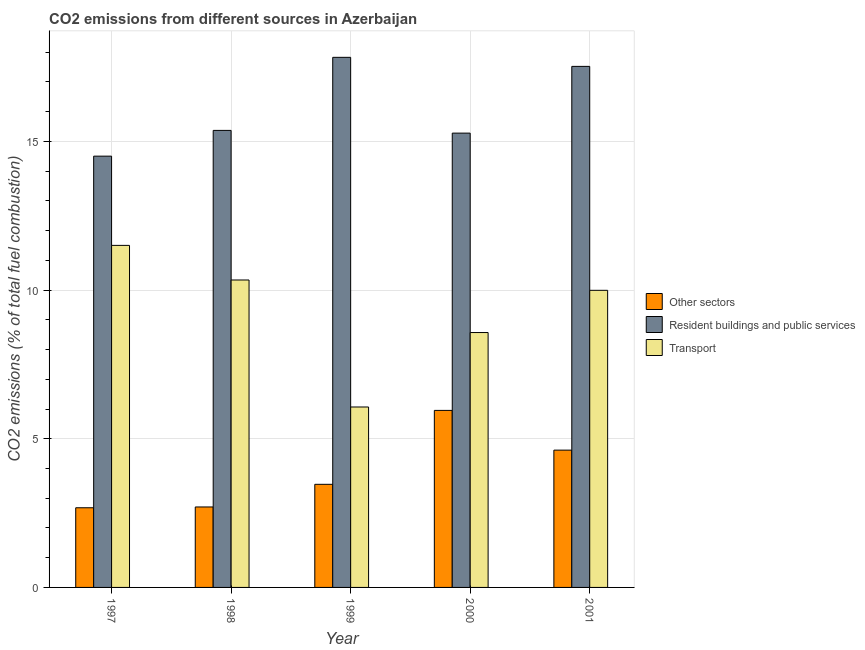How many different coloured bars are there?
Your answer should be compact. 3. How many bars are there on the 5th tick from the left?
Keep it short and to the point. 3. What is the label of the 1st group of bars from the left?
Your response must be concise. 1997. In how many cases, is the number of bars for a given year not equal to the number of legend labels?
Offer a very short reply. 0. What is the percentage of co2 emissions from resident buildings and public services in 1997?
Offer a very short reply. 14.51. Across all years, what is the maximum percentage of co2 emissions from other sectors?
Make the answer very short. 5.95. Across all years, what is the minimum percentage of co2 emissions from other sectors?
Keep it short and to the point. 2.68. What is the total percentage of co2 emissions from other sectors in the graph?
Make the answer very short. 19.43. What is the difference between the percentage of co2 emissions from resident buildings and public services in 1997 and that in 1999?
Ensure brevity in your answer.  -3.32. What is the difference between the percentage of co2 emissions from other sectors in 2000 and the percentage of co2 emissions from resident buildings and public services in 2001?
Keep it short and to the point. 1.34. What is the average percentage of co2 emissions from transport per year?
Offer a very short reply. 9.3. In the year 1998, what is the difference between the percentage of co2 emissions from other sectors and percentage of co2 emissions from transport?
Your answer should be very brief. 0. What is the ratio of the percentage of co2 emissions from other sectors in 1997 to that in 1999?
Provide a succinct answer. 0.77. Is the percentage of co2 emissions from resident buildings and public services in 1997 less than that in 2000?
Offer a terse response. Yes. What is the difference between the highest and the second highest percentage of co2 emissions from resident buildings and public services?
Your response must be concise. 0.3. What is the difference between the highest and the lowest percentage of co2 emissions from transport?
Give a very brief answer. 5.44. In how many years, is the percentage of co2 emissions from resident buildings and public services greater than the average percentage of co2 emissions from resident buildings and public services taken over all years?
Provide a short and direct response. 2. Is the sum of the percentage of co2 emissions from transport in 1999 and 2000 greater than the maximum percentage of co2 emissions from other sectors across all years?
Offer a very short reply. Yes. What does the 3rd bar from the left in 2001 represents?
Make the answer very short. Transport. What does the 1st bar from the right in 2001 represents?
Your answer should be very brief. Transport. How many bars are there?
Provide a succinct answer. 15. Are all the bars in the graph horizontal?
Offer a very short reply. No. How many years are there in the graph?
Make the answer very short. 5. Does the graph contain grids?
Keep it short and to the point. Yes. Where does the legend appear in the graph?
Ensure brevity in your answer.  Center right. What is the title of the graph?
Provide a succinct answer. CO2 emissions from different sources in Azerbaijan. What is the label or title of the Y-axis?
Keep it short and to the point. CO2 emissions (% of total fuel combustion). What is the CO2 emissions (% of total fuel combustion) in Other sectors in 1997?
Keep it short and to the point. 2.68. What is the CO2 emissions (% of total fuel combustion) of Resident buildings and public services in 1997?
Your answer should be very brief. 14.51. What is the CO2 emissions (% of total fuel combustion) in Transport in 1997?
Give a very brief answer. 11.5. What is the CO2 emissions (% of total fuel combustion) of Other sectors in 1998?
Offer a terse response. 2.71. What is the CO2 emissions (% of total fuel combustion) of Resident buildings and public services in 1998?
Your answer should be compact. 15.37. What is the CO2 emissions (% of total fuel combustion) in Transport in 1998?
Your response must be concise. 10.34. What is the CO2 emissions (% of total fuel combustion) in Other sectors in 1999?
Provide a succinct answer. 3.47. What is the CO2 emissions (% of total fuel combustion) in Resident buildings and public services in 1999?
Give a very brief answer. 17.83. What is the CO2 emissions (% of total fuel combustion) in Transport in 1999?
Your response must be concise. 6.07. What is the CO2 emissions (% of total fuel combustion) of Other sectors in 2000?
Give a very brief answer. 5.95. What is the CO2 emissions (% of total fuel combustion) in Resident buildings and public services in 2000?
Give a very brief answer. 15.28. What is the CO2 emissions (% of total fuel combustion) in Transport in 2000?
Make the answer very short. 8.57. What is the CO2 emissions (% of total fuel combustion) of Other sectors in 2001?
Provide a succinct answer. 4.62. What is the CO2 emissions (% of total fuel combustion) of Resident buildings and public services in 2001?
Your response must be concise. 17.52. What is the CO2 emissions (% of total fuel combustion) in Transport in 2001?
Provide a succinct answer. 9.99. Across all years, what is the maximum CO2 emissions (% of total fuel combustion) in Other sectors?
Your response must be concise. 5.95. Across all years, what is the maximum CO2 emissions (% of total fuel combustion) of Resident buildings and public services?
Offer a terse response. 17.83. Across all years, what is the maximum CO2 emissions (% of total fuel combustion) of Transport?
Ensure brevity in your answer.  11.5. Across all years, what is the minimum CO2 emissions (% of total fuel combustion) of Other sectors?
Make the answer very short. 2.68. Across all years, what is the minimum CO2 emissions (% of total fuel combustion) of Resident buildings and public services?
Give a very brief answer. 14.51. Across all years, what is the minimum CO2 emissions (% of total fuel combustion) in Transport?
Offer a very short reply. 6.07. What is the total CO2 emissions (% of total fuel combustion) of Other sectors in the graph?
Your answer should be very brief. 19.43. What is the total CO2 emissions (% of total fuel combustion) of Resident buildings and public services in the graph?
Ensure brevity in your answer.  80.51. What is the total CO2 emissions (% of total fuel combustion) of Transport in the graph?
Keep it short and to the point. 46.48. What is the difference between the CO2 emissions (% of total fuel combustion) in Other sectors in 1997 and that in 1998?
Provide a short and direct response. -0.03. What is the difference between the CO2 emissions (% of total fuel combustion) in Resident buildings and public services in 1997 and that in 1998?
Give a very brief answer. -0.87. What is the difference between the CO2 emissions (% of total fuel combustion) in Transport in 1997 and that in 1998?
Offer a terse response. 1.16. What is the difference between the CO2 emissions (% of total fuel combustion) of Other sectors in 1997 and that in 1999?
Provide a succinct answer. -0.79. What is the difference between the CO2 emissions (% of total fuel combustion) in Resident buildings and public services in 1997 and that in 1999?
Ensure brevity in your answer.  -3.32. What is the difference between the CO2 emissions (% of total fuel combustion) of Transport in 1997 and that in 1999?
Your response must be concise. 5.44. What is the difference between the CO2 emissions (% of total fuel combustion) of Other sectors in 1997 and that in 2000?
Ensure brevity in your answer.  -3.27. What is the difference between the CO2 emissions (% of total fuel combustion) in Resident buildings and public services in 1997 and that in 2000?
Ensure brevity in your answer.  -0.77. What is the difference between the CO2 emissions (% of total fuel combustion) in Transport in 1997 and that in 2000?
Your answer should be very brief. 2.93. What is the difference between the CO2 emissions (% of total fuel combustion) in Other sectors in 1997 and that in 2001?
Provide a succinct answer. -1.94. What is the difference between the CO2 emissions (% of total fuel combustion) of Resident buildings and public services in 1997 and that in 2001?
Make the answer very short. -3.02. What is the difference between the CO2 emissions (% of total fuel combustion) of Transport in 1997 and that in 2001?
Keep it short and to the point. 1.51. What is the difference between the CO2 emissions (% of total fuel combustion) of Other sectors in 1998 and that in 1999?
Your response must be concise. -0.76. What is the difference between the CO2 emissions (% of total fuel combustion) of Resident buildings and public services in 1998 and that in 1999?
Your response must be concise. -2.46. What is the difference between the CO2 emissions (% of total fuel combustion) in Transport in 1998 and that in 1999?
Your answer should be compact. 4.27. What is the difference between the CO2 emissions (% of total fuel combustion) in Other sectors in 1998 and that in 2000?
Provide a short and direct response. -3.25. What is the difference between the CO2 emissions (% of total fuel combustion) of Resident buildings and public services in 1998 and that in 2000?
Provide a succinct answer. 0.09. What is the difference between the CO2 emissions (% of total fuel combustion) in Transport in 1998 and that in 2000?
Keep it short and to the point. 1.77. What is the difference between the CO2 emissions (% of total fuel combustion) of Other sectors in 1998 and that in 2001?
Offer a terse response. -1.91. What is the difference between the CO2 emissions (% of total fuel combustion) in Resident buildings and public services in 1998 and that in 2001?
Your answer should be very brief. -2.15. What is the difference between the CO2 emissions (% of total fuel combustion) in Transport in 1998 and that in 2001?
Ensure brevity in your answer.  0.35. What is the difference between the CO2 emissions (% of total fuel combustion) in Other sectors in 1999 and that in 2000?
Make the answer very short. -2.49. What is the difference between the CO2 emissions (% of total fuel combustion) of Resident buildings and public services in 1999 and that in 2000?
Your response must be concise. 2.55. What is the difference between the CO2 emissions (% of total fuel combustion) in Transport in 1999 and that in 2000?
Make the answer very short. -2.5. What is the difference between the CO2 emissions (% of total fuel combustion) of Other sectors in 1999 and that in 2001?
Your answer should be very brief. -1.15. What is the difference between the CO2 emissions (% of total fuel combustion) of Resident buildings and public services in 1999 and that in 2001?
Provide a succinct answer. 0.3. What is the difference between the CO2 emissions (% of total fuel combustion) in Transport in 1999 and that in 2001?
Your answer should be compact. -3.92. What is the difference between the CO2 emissions (% of total fuel combustion) in Other sectors in 2000 and that in 2001?
Keep it short and to the point. 1.34. What is the difference between the CO2 emissions (% of total fuel combustion) of Resident buildings and public services in 2000 and that in 2001?
Provide a succinct answer. -2.24. What is the difference between the CO2 emissions (% of total fuel combustion) in Transport in 2000 and that in 2001?
Provide a short and direct response. -1.42. What is the difference between the CO2 emissions (% of total fuel combustion) of Other sectors in 1997 and the CO2 emissions (% of total fuel combustion) of Resident buildings and public services in 1998?
Give a very brief answer. -12.69. What is the difference between the CO2 emissions (% of total fuel combustion) of Other sectors in 1997 and the CO2 emissions (% of total fuel combustion) of Transport in 1998?
Your answer should be compact. -7.66. What is the difference between the CO2 emissions (% of total fuel combustion) in Resident buildings and public services in 1997 and the CO2 emissions (% of total fuel combustion) in Transport in 1998?
Your answer should be very brief. 4.17. What is the difference between the CO2 emissions (% of total fuel combustion) of Other sectors in 1997 and the CO2 emissions (% of total fuel combustion) of Resident buildings and public services in 1999?
Ensure brevity in your answer.  -15.15. What is the difference between the CO2 emissions (% of total fuel combustion) in Other sectors in 1997 and the CO2 emissions (% of total fuel combustion) in Transport in 1999?
Give a very brief answer. -3.39. What is the difference between the CO2 emissions (% of total fuel combustion) of Resident buildings and public services in 1997 and the CO2 emissions (% of total fuel combustion) of Transport in 1999?
Provide a short and direct response. 8.44. What is the difference between the CO2 emissions (% of total fuel combustion) of Other sectors in 1997 and the CO2 emissions (% of total fuel combustion) of Resident buildings and public services in 2000?
Provide a succinct answer. -12.6. What is the difference between the CO2 emissions (% of total fuel combustion) in Other sectors in 1997 and the CO2 emissions (% of total fuel combustion) in Transport in 2000?
Provide a succinct answer. -5.89. What is the difference between the CO2 emissions (% of total fuel combustion) of Resident buildings and public services in 1997 and the CO2 emissions (% of total fuel combustion) of Transport in 2000?
Offer a terse response. 5.93. What is the difference between the CO2 emissions (% of total fuel combustion) in Other sectors in 1997 and the CO2 emissions (% of total fuel combustion) in Resident buildings and public services in 2001?
Give a very brief answer. -14.85. What is the difference between the CO2 emissions (% of total fuel combustion) in Other sectors in 1997 and the CO2 emissions (% of total fuel combustion) in Transport in 2001?
Provide a succinct answer. -7.31. What is the difference between the CO2 emissions (% of total fuel combustion) of Resident buildings and public services in 1997 and the CO2 emissions (% of total fuel combustion) of Transport in 2001?
Provide a short and direct response. 4.51. What is the difference between the CO2 emissions (% of total fuel combustion) in Other sectors in 1998 and the CO2 emissions (% of total fuel combustion) in Resident buildings and public services in 1999?
Make the answer very short. -15.12. What is the difference between the CO2 emissions (% of total fuel combustion) of Other sectors in 1998 and the CO2 emissions (% of total fuel combustion) of Transport in 1999?
Your answer should be compact. -3.36. What is the difference between the CO2 emissions (% of total fuel combustion) in Resident buildings and public services in 1998 and the CO2 emissions (% of total fuel combustion) in Transport in 1999?
Offer a very short reply. 9.3. What is the difference between the CO2 emissions (% of total fuel combustion) of Other sectors in 1998 and the CO2 emissions (% of total fuel combustion) of Resident buildings and public services in 2000?
Your response must be concise. -12.57. What is the difference between the CO2 emissions (% of total fuel combustion) of Other sectors in 1998 and the CO2 emissions (% of total fuel combustion) of Transport in 2000?
Your answer should be very brief. -5.87. What is the difference between the CO2 emissions (% of total fuel combustion) in Resident buildings and public services in 1998 and the CO2 emissions (% of total fuel combustion) in Transport in 2000?
Keep it short and to the point. 6.8. What is the difference between the CO2 emissions (% of total fuel combustion) in Other sectors in 1998 and the CO2 emissions (% of total fuel combustion) in Resident buildings and public services in 2001?
Give a very brief answer. -14.82. What is the difference between the CO2 emissions (% of total fuel combustion) in Other sectors in 1998 and the CO2 emissions (% of total fuel combustion) in Transport in 2001?
Your response must be concise. -7.29. What is the difference between the CO2 emissions (% of total fuel combustion) in Resident buildings and public services in 1998 and the CO2 emissions (% of total fuel combustion) in Transport in 2001?
Your answer should be compact. 5.38. What is the difference between the CO2 emissions (% of total fuel combustion) of Other sectors in 1999 and the CO2 emissions (% of total fuel combustion) of Resident buildings and public services in 2000?
Your response must be concise. -11.81. What is the difference between the CO2 emissions (% of total fuel combustion) in Other sectors in 1999 and the CO2 emissions (% of total fuel combustion) in Transport in 2000?
Provide a succinct answer. -5.1. What is the difference between the CO2 emissions (% of total fuel combustion) of Resident buildings and public services in 1999 and the CO2 emissions (% of total fuel combustion) of Transport in 2000?
Your answer should be very brief. 9.26. What is the difference between the CO2 emissions (% of total fuel combustion) of Other sectors in 1999 and the CO2 emissions (% of total fuel combustion) of Resident buildings and public services in 2001?
Provide a short and direct response. -14.06. What is the difference between the CO2 emissions (% of total fuel combustion) of Other sectors in 1999 and the CO2 emissions (% of total fuel combustion) of Transport in 2001?
Your answer should be compact. -6.52. What is the difference between the CO2 emissions (% of total fuel combustion) of Resident buildings and public services in 1999 and the CO2 emissions (% of total fuel combustion) of Transport in 2001?
Provide a short and direct response. 7.84. What is the difference between the CO2 emissions (% of total fuel combustion) in Other sectors in 2000 and the CO2 emissions (% of total fuel combustion) in Resident buildings and public services in 2001?
Provide a short and direct response. -11.57. What is the difference between the CO2 emissions (% of total fuel combustion) of Other sectors in 2000 and the CO2 emissions (% of total fuel combustion) of Transport in 2001?
Ensure brevity in your answer.  -4.04. What is the difference between the CO2 emissions (% of total fuel combustion) of Resident buildings and public services in 2000 and the CO2 emissions (% of total fuel combustion) of Transport in 2001?
Give a very brief answer. 5.29. What is the average CO2 emissions (% of total fuel combustion) in Other sectors per year?
Ensure brevity in your answer.  3.89. What is the average CO2 emissions (% of total fuel combustion) in Resident buildings and public services per year?
Your answer should be compact. 16.1. What is the average CO2 emissions (% of total fuel combustion) in Transport per year?
Ensure brevity in your answer.  9.3. In the year 1997, what is the difference between the CO2 emissions (% of total fuel combustion) in Other sectors and CO2 emissions (% of total fuel combustion) in Resident buildings and public services?
Your response must be concise. -11.83. In the year 1997, what is the difference between the CO2 emissions (% of total fuel combustion) in Other sectors and CO2 emissions (% of total fuel combustion) in Transport?
Your response must be concise. -8.82. In the year 1997, what is the difference between the CO2 emissions (% of total fuel combustion) of Resident buildings and public services and CO2 emissions (% of total fuel combustion) of Transport?
Make the answer very short. 3. In the year 1998, what is the difference between the CO2 emissions (% of total fuel combustion) in Other sectors and CO2 emissions (% of total fuel combustion) in Resident buildings and public services?
Give a very brief answer. -12.66. In the year 1998, what is the difference between the CO2 emissions (% of total fuel combustion) of Other sectors and CO2 emissions (% of total fuel combustion) of Transport?
Offer a terse response. -7.63. In the year 1998, what is the difference between the CO2 emissions (% of total fuel combustion) in Resident buildings and public services and CO2 emissions (% of total fuel combustion) in Transport?
Your response must be concise. 5.03. In the year 1999, what is the difference between the CO2 emissions (% of total fuel combustion) in Other sectors and CO2 emissions (% of total fuel combustion) in Resident buildings and public services?
Provide a succinct answer. -14.36. In the year 1999, what is the difference between the CO2 emissions (% of total fuel combustion) in Other sectors and CO2 emissions (% of total fuel combustion) in Transport?
Provide a succinct answer. -2.6. In the year 1999, what is the difference between the CO2 emissions (% of total fuel combustion) of Resident buildings and public services and CO2 emissions (% of total fuel combustion) of Transport?
Make the answer very short. 11.76. In the year 2000, what is the difference between the CO2 emissions (% of total fuel combustion) in Other sectors and CO2 emissions (% of total fuel combustion) in Resident buildings and public services?
Your answer should be compact. -9.33. In the year 2000, what is the difference between the CO2 emissions (% of total fuel combustion) in Other sectors and CO2 emissions (% of total fuel combustion) in Transport?
Provide a short and direct response. -2.62. In the year 2000, what is the difference between the CO2 emissions (% of total fuel combustion) of Resident buildings and public services and CO2 emissions (% of total fuel combustion) of Transport?
Your answer should be very brief. 6.71. In the year 2001, what is the difference between the CO2 emissions (% of total fuel combustion) in Other sectors and CO2 emissions (% of total fuel combustion) in Resident buildings and public services?
Ensure brevity in your answer.  -12.91. In the year 2001, what is the difference between the CO2 emissions (% of total fuel combustion) in Other sectors and CO2 emissions (% of total fuel combustion) in Transport?
Keep it short and to the point. -5.37. In the year 2001, what is the difference between the CO2 emissions (% of total fuel combustion) in Resident buildings and public services and CO2 emissions (% of total fuel combustion) in Transport?
Your answer should be very brief. 7.53. What is the ratio of the CO2 emissions (% of total fuel combustion) of Resident buildings and public services in 1997 to that in 1998?
Ensure brevity in your answer.  0.94. What is the ratio of the CO2 emissions (% of total fuel combustion) in Transport in 1997 to that in 1998?
Your answer should be compact. 1.11. What is the ratio of the CO2 emissions (% of total fuel combustion) of Other sectors in 1997 to that in 1999?
Offer a very short reply. 0.77. What is the ratio of the CO2 emissions (% of total fuel combustion) in Resident buildings and public services in 1997 to that in 1999?
Your answer should be compact. 0.81. What is the ratio of the CO2 emissions (% of total fuel combustion) in Transport in 1997 to that in 1999?
Ensure brevity in your answer.  1.9. What is the ratio of the CO2 emissions (% of total fuel combustion) in Other sectors in 1997 to that in 2000?
Ensure brevity in your answer.  0.45. What is the ratio of the CO2 emissions (% of total fuel combustion) in Resident buildings and public services in 1997 to that in 2000?
Your answer should be compact. 0.95. What is the ratio of the CO2 emissions (% of total fuel combustion) in Transport in 1997 to that in 2000?
Ensure brevity in your answer.  1.34. What is the ratio of the CO2 emissions (% of total fuel combustion) in Other sectors in 1997 to that in 2001?
Provide a short and direct response. 0.58. What is the ratio of the CO2 emissions (% of total fuel combustion) in Resident buildings and public services in 1997 to that in 2001?
Your answer should be compact. 0.83. What is the ratio of the CO2 emissions (% of total fuel combustion) of Transport in 1997 to that in 2001?
Your answer should be very brief. 1.15. What is the ratio of the CO2 emissions (% of total fuel combustion) in Other sectors in 1998 to that in 1999?
Make the answer very short. 0.78. What is the ratio of the CO2 emissions (% of total fuel combustion) in Resident buildings and public services in 1998 to that in 1999?
Your answer should be compact. 0.86. What is the ratio of the CO2 emissions (% of total fuel combustion) of Transport in 1998 to that in 1999?
Keep it short and to the point. 1.7. What is the ratio of the CO2 emissions (% of total fuel combustion) of Other sectors in 1998 to that in 2000?
Provide a succinct answer. 0.45. What is the ratio of the CO2 emissions (% of total fuel combustion) of Transport in 1998 to that in 2000?
Offer a very short reply. 1.21. What is the ratio of the CO2 emissions (% of total fuel combustion) of Other sectors in 1998 to that in 2001?
Ensure brevity in your answer.  0.59. What is the ratio of the CO2 emissions (% of total fuel combustion) in Resident buildings and public services in 1998 to that in 2001?
Your response must be concise. 0.88. What is the ratio of the CO2 emissions (% of total fuel combustion) in Transport in 1998 to that in 2001?
Make the answer very short. 1.03. What is the ratio of the CO2 emissions (% of total fuel combustion) of Other sectors in 1999 to that in 2000?
Your answer should be compact. 0.58. What is the ratio of the CO2 emissions (% of total fuel combustion) of Resident buildings and public services in 1999 to that in 2000?
Give a very brief answer. 1.17. What is the ratio of the CO2 emissions (% of total fuel combustion) of Transport in 1999 to that in 2000?
Give a very brief answer. 0.71. What is the ratio of the CO2 emissions (% of total fuel combustion) of Other sectors in 1999 to that in 2001?
Provide a short and direct response. 0.75. What is the ratio of the CO2 emissions (% of total fuel combustion) of Resident buildings and public services in 1999 to that in 2001?
Provide a short and direct response. 1.02. What is the ratio of the CO2 emissions (% of total fuel combustion) in Transport in 1999 to that in 2001?
Your response must be concise. 0.61. What is the ratio of the CO2 emissions (% of total fuel combustion) in Other sectors in 2000 to that in 2001?
Provide a succinct answer. 1.29. What is the ratio of the CO2 emissions (% of total fuel combustion) in Resident buildings and public services in 2000 to that in 2001?
Offer a very short reply. 0.87. What is the ratio of the CO2 emissions (% of total fuel combustion) of Transport in 2000 to that in 2001?
Make the answer very short. 0.86. What is the difference between the highest and the second highest CO2 emissions (% of total fuel combustion) of Other sectors?
Provide a succinct answer. 1.34. What is the difference between the highest and the second highest CO2 emissions (% of total fuel combustion) of Resident buildings and public services?
Keep it short and to the point. 0.3. What is the difference between the highest and the second highest CO2 emissions (% of total fuel combustion) in Transport?
Keep it short and to the point. 1.16. What is the difference between the highest and the lowest CO2 emissions (% of total fuel combustion) in Other sectors?
Provide a short and direct response. 3.27. What is the difference between the highest and the lowest CO2 emissions (% of total fuel combustion) in Resident buildings and public services?
Offer a very short reply. 3.32. What is the difference between the highest and the lowest CO2 emissions (% of total fuel combustion) in Transport?
Keep it short and to the point. 5.44. 